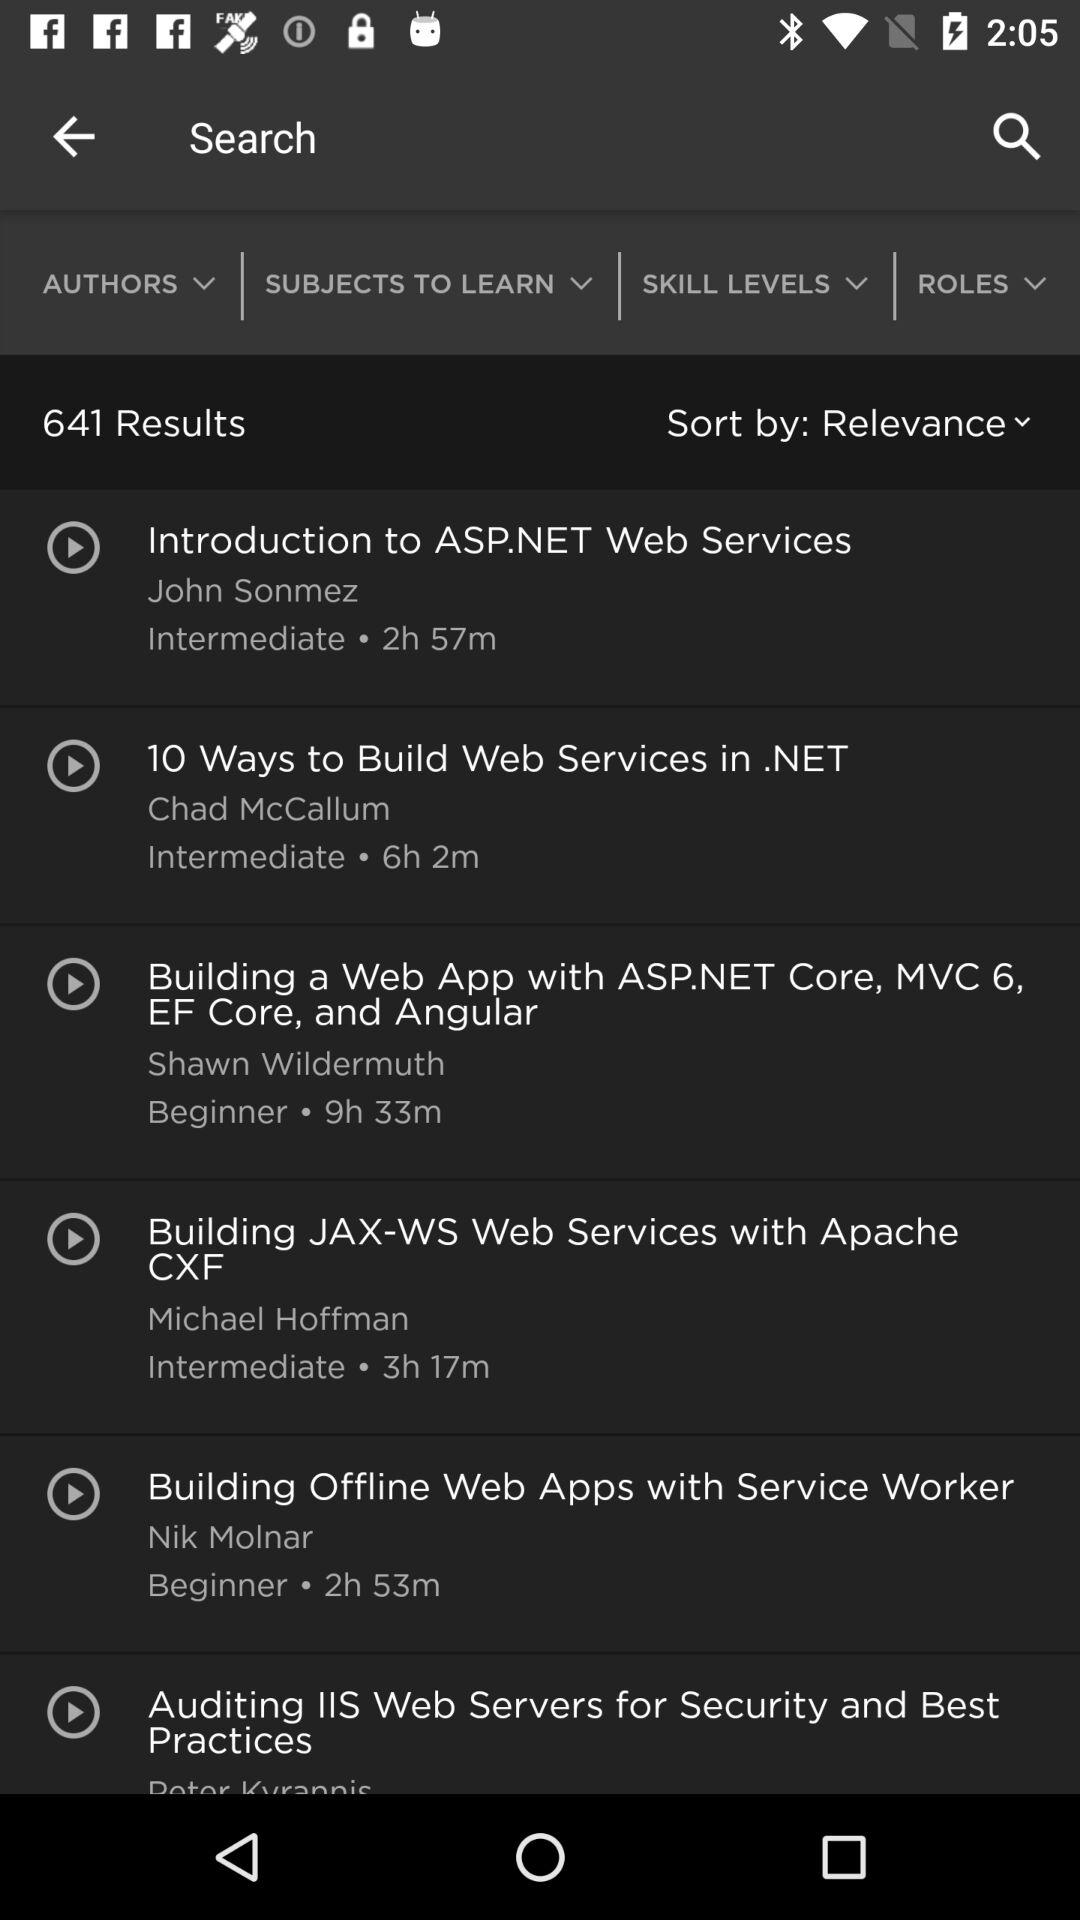Which category is chosen in the "Sort by"? The chosen category is "Relevance". 